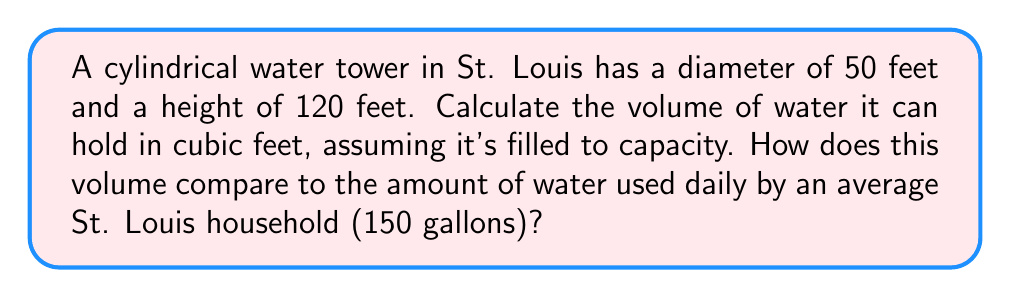Provide a solution to this math problem. 1. Calculate the volume of the cylindrical water tower:
   The volume of a cylinder is given by the formula:
   $$V = \pi r^2 h$$
   where $r$ is the radius and $h$ is the height.

   Radius = Diameter / 2 = 50 / 2 = 25 feet
   
   $$V = \pi (25\text{ ft})^2 (120\text{ ft})$$
   $$V = 235,619.45\text{ cubic feet}$$

2. Convert cubic feet to gallons:
   1 cubic foot ≈ 7.48052 gallons
   
   $$235,619.45\text{ ft}^3 \times 7.48052\text{ gal/ft}^3 = 1,762,565.12\text{ gallons}$$

3. Compare to average household usage:
   $$\frac{1,762,565.12\text{ gallons}}{150\text{ gallons/household}} \approx 11,750.43\text{ households}$$

[asy]
import geometry;

real r = 25;
real h = 120;
real scale = 1.5;

path p = (0,0)--(0,h)::(r,0)--(r,h)::(-r,0)--(-r,h);
draw(surface(p,c=O,axis=Z), lightblue+opacity(0.5));
draw(p, blue);

draw(circle((0,0,0),r), blue);
draw(circle((0,h,0),r), blue);

label("50 ft", (r,-5), E);
label("120 ft", (r+5,h/2), E);

shipout(scale(scale)*currentpicture);
[/asy]
Answer: 235,619.45 cubic feet; equivalent to ~11,750 households' daily water use 